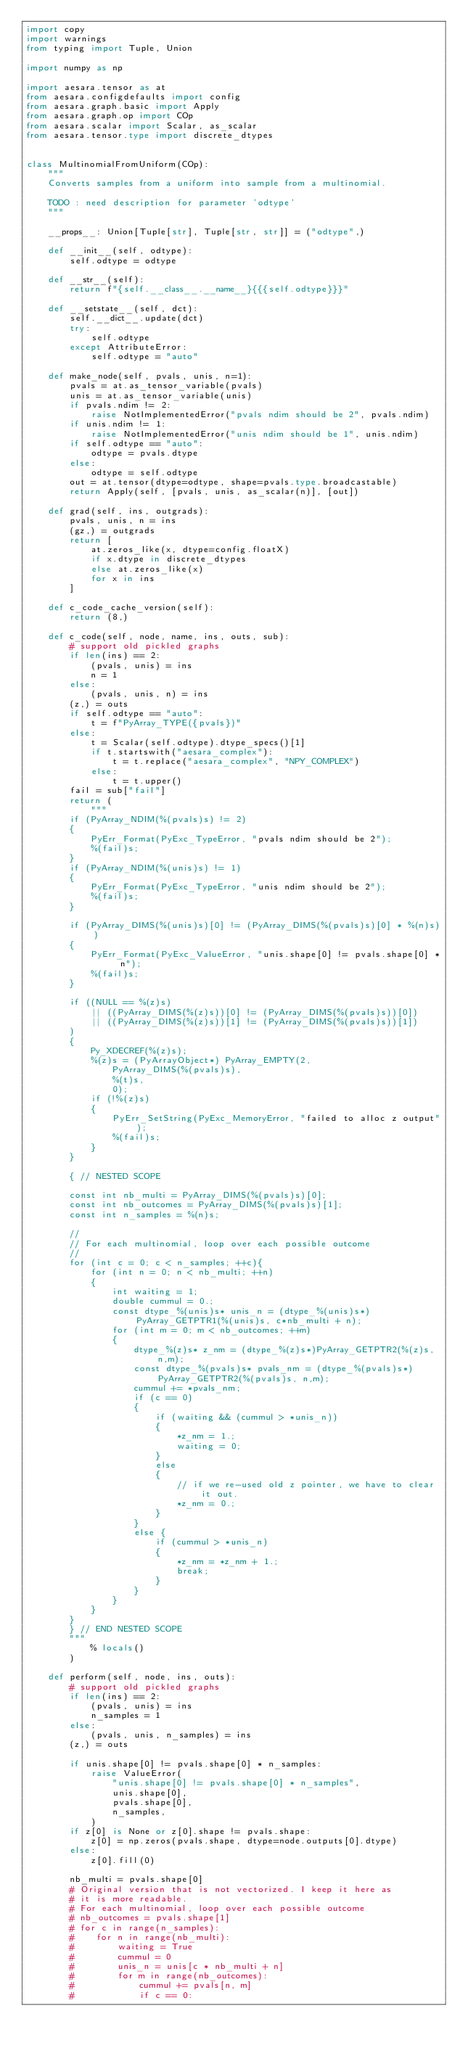<code> <loc_0><loc_0><loc_500><loc_500><_Python_>import copy
import warnings
from typing import Tuple, Union

import numpy as np

import aesara.tensor as at
from aesara.configdefaults import config
from aesara.graph.basic import Apply
from aesara.graph.op import COp
from aesara.scalar import Scalar, as_scalar
from aesara.tensor.type import discrete_dtypes


class MultinomialFromUniform(COp):
    """
    Converts samples from a uniform into sample from a multinomial.

    TODO : need description for parameter 'odtype'
    """

    __props__: Union[Tuple[str], Tuple[str, str]] = ("odtype",)

    def __init__(self, odtype):
        self.odtype = odtype

    def __str__(self):
        return f"{self.__class__.__name__}{{{self.odtype}}}"

    def __setstate__(self, dct):
        self.__dict__.update(dct)
        try:
            self.odtype
        except AttributeError:
            self.odtype = "auto"

    def make_node(self, pvals, unis, n=1):
        pvals = at.as_tensor_variable(pvals)
        unis = at.as_tensor_variable(unis)
        if pvals.ndim != 2:
            raise NotImplementedError("pvals ndim should be 2", pvals.ndim)
        if unis.ndim != 1:
            raise NotImplementedError("unis ndim should be 1", unis.ndim)
        if self.odtype == "auto":
            odtype = pvals.dtype
        else:
            odtype = self.odtype
        out = at.tensor(dtype=odtype, shape=pvals.type.broadcastable)
        return Apply(self, [pvals, unis, as_scalar(n)], [out])

    def grad(self, ins, outgrads):
        pvals, unis, n = ins
        (gz,) = outgrads
        return [
            at.zeros_like(x, dtype=config.floatX)
            if x.dtype in discrete_dtypes
            else at.zeros_like(x)
            for x in ins
        ]

    def c_code_cache_version(self):
        return (8,)

    def c_code(self, node, name, ins, outs, sub):
        # support old pickled graphs
        if len(ins) == 2:
            (pvals, unis) = ins
            n = 1
        else:
            (pvals, unis, n) = ins
        (z,) = outs
        if self.odtype == "auto":
            t = f"PyArray_TYPE({pvals})"
        else:
            t = Scalar(self.odtype).dtype_specs()[1]
            if t.startswith("aesara_complex"):
                t = t.replace("aesara_complex", "NPY_COMPLEX")
            else:
                t = t.upper()
        fail = sub["fail"]
        return (
            """
        if (PyArray_NDIM(%(pvals)s) != 2)
        {
            PyErr_Format(PyExc_TypeError, "pvals ndim should be 2");
            %(fail)s;
        }
        if (PyArray_NDIM(%(unis)s) != 1)
        {
            PyErr_Format(PyExc_TypeError, "unis ndim should be 2");
            %(fail)s;
        }

        if (PyArray_DIMS(%(unis)s)[0] != (PyArray_DIMS(%(pvals)s)[0] * %(n)s))
        {
            PyErr_Format(PyExc_ValueError, "unis.shape[0] != pvals.shape[0] * n");
            %(fail)s;
        }

        if ((NULL == %(z)s)
            || ((PyArray_DIMS(%(z)s))[0] != (PyArray_DIMS(%(pvals)s))[0])
            || ((PyArray_DIMS(%(z)s))[1] != (PyArray_DIMS(%(pvals)s))[1])
        )
        {
            Py_XDECREF(%(z)s);
            %(z)s = (PyArrayObject*) PyArray_EMPTY(2,
                PyArray_DIMS(%(pvals)s),
                %(t)s,
                0);
            if (!%(z)s)
            {
                PyErr_SetString(PyExc_MemoryError, "failed to alloc z output");
                %(fail)s;
            }
        }

        { // NESTED SCOPE

        const int nb_multi = PyArray_DIMS(%(pvals)s)[0];
        const int nb_outcomes = PyArray_DIMS(%(pvals)s)[1];
        const int n_samples = %(n)s;

        //
        // For each multinomial, loop over each possible outcome
        //
        for (int c = 0; c < n_samples; ++c){
            for (int n = 0; n < nb_multi; ++n)
            {
                int waiting = 1;
                double cummul = 0.;
                const dtype_%(unis)s* unis_n = (dtype_%(unis)s*)PyArray_GETPTR1(%(unis)s, c*nb_multi + n);
                for (int m = 0; m < nb_outcomes; ++m)
                {
                    dtype_%(z)s* z_nm = (dtype_%(z)s*)PyArray_GETPTR2(%(z)s, n,m);
                    const dtype_%(pvals)s* pvals_nm = (dtype_%(pvals)s*)PyArray_GETPTR2(%(pvals)s, n,m);
                    cummul += *pvals_nm;
                    if (c == 0)
                    {
                        if (waiting && (cummul > *unis_n))
                        {
                            *z_nm = 1.;
                            waiting = 0;
                        }
                        else
                        {
                            // if we re-used old z pointer, we have to clear it out.
                            *z_nm = 0.;
                        }
                    }
                    else {
                        if (cummul > *unis_n)
                        {
                            *z_nm = *z_nm + 1.;
                            break;
                        }
                    }
                }
            }
        }
        } // END NESTED SCOPE
        """
            % locals()
        )

    def perform(self, node, ins, outs):
        # support old pickled graphs
        if len(ins) == 2:
            (pvals, unis) = ins
            n_samples = 1
        else:
            (pvals, unis, n_samples) = ins
        (z,) = outs

        if unis.shape[0] != pvals.shape[0] * n_samples:
            raise ValueError(
                "unis.shape[0] != pvals.shape[0] * n_samples",
                unis.shape[0],
                pvals.shape[0],
                n_samples,
            )
        if z[0] is None or z[0].shape != pvals.shape:
            z[0] = np.zeros(pvals.shape, dtype=node.outputs[0].dtype)
        else:
            z[0].fill(0)

        nb_multi = pvals.shape[0]
        # Original version that is not vectorized. I keep it here as
        # it is more readable.
        # For each multinomial, loop over each possible outcome
        # nb_outcomes = pvals.shape[1]
        # for c in range(n_samples):
        #    for n in range(nb_multi):
        #        waiting = True
        #        cummul = 0
        #        unis_n = unis[c * nb_multi + n]
        #        for m in range(nb_outcomes):
        #            cummul += pvals[n, m]
        #            if c == 0:</code> 